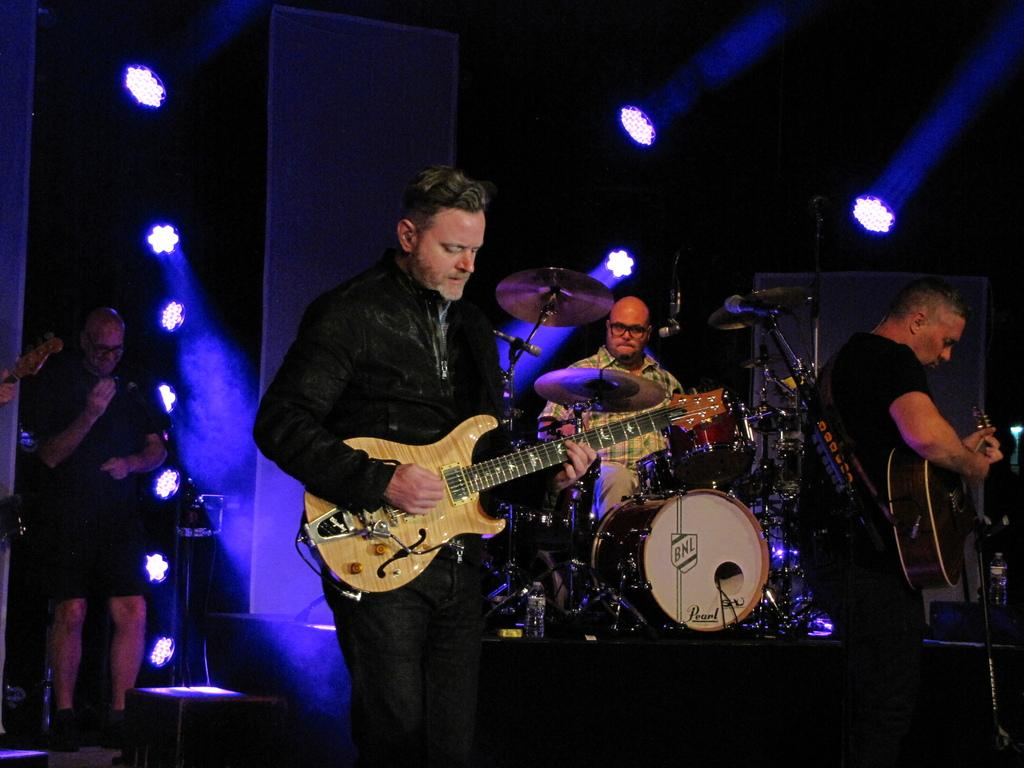What is the setting of the image? The image is of the inside of a room. How many people are in the image? There are three persons in the image. What are the persons doing in the image? The persons are playing music. Can you describe the musical instrument held by one of the persons? At least one person is holding a guitar. Where is the person standing in the image? There is a person standing on the right side of the image. What can be seen on the left side of the image? There are lights on the left side of the image. What type of chess piece is the person holding in the image? There is no chess piece present in the image; the persons are playing music and holding a guitar. What part of the queen's attire can be seen in the image? There is no queen or any attire related to a queen present in the image. 